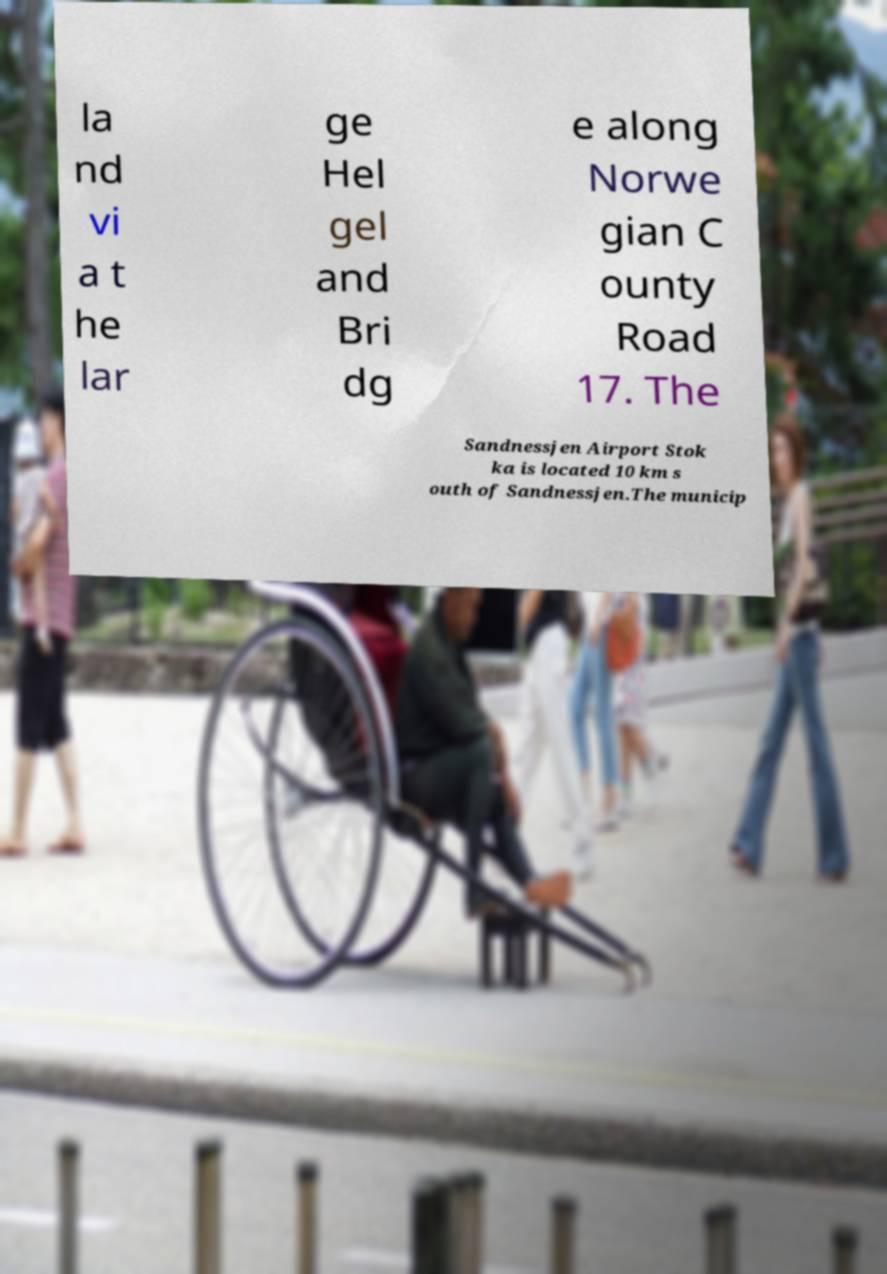Can you read and provide the text displayed in the image?This photo seems to have some interesting text. Can you extract and type it out for me? la nd vi a t he lar ge Hel gel and Bri dg e along Norwe gian C ounty Road 17. The Sandnessjen Airport Stok ka is located 10 km s outh of Sandnessjen.The municip 